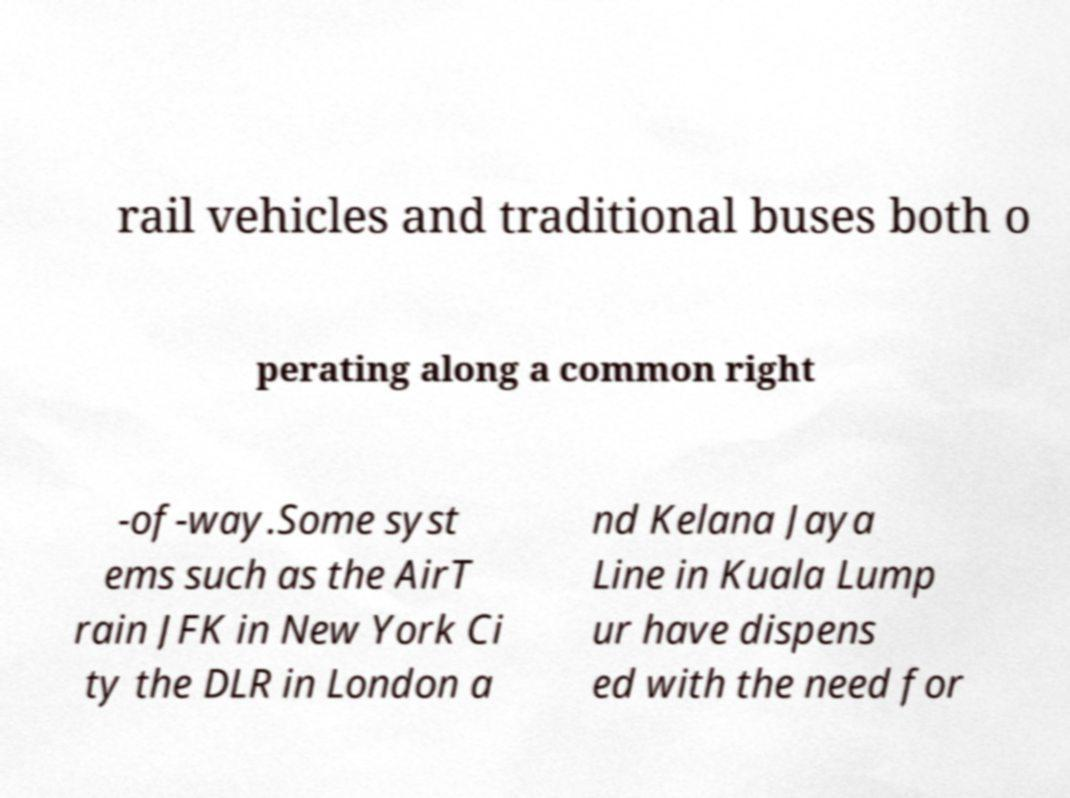I need the written content from this picture converted into text. Can you do that? rail vehicles and traditional buses both o perating along a common right -of-way.Some syst ems such as the AirT rain JFK in New York Ci ty the DLR in London a nd Kelana Jaya Line in Kuala Lump ur have dispens ed with the need for 